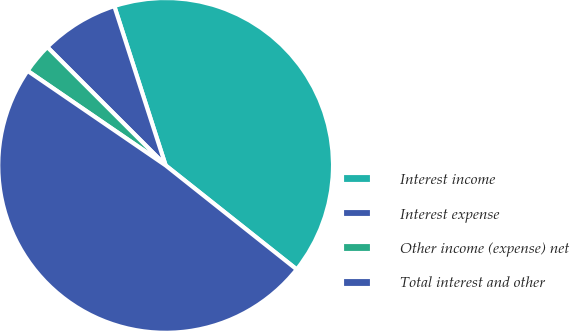Convert chart. <chart><loc_0><loc_0><loc_500><loc_500><pie_chart><fcel>Interest income<fcel>Interest expense<fcel>Other income (expense) net<fcel>Total interest and other<nl><fcel>40.64%<fcel>7.54%<fcel>2.94%<fcel>48.88%<nl></chart> 